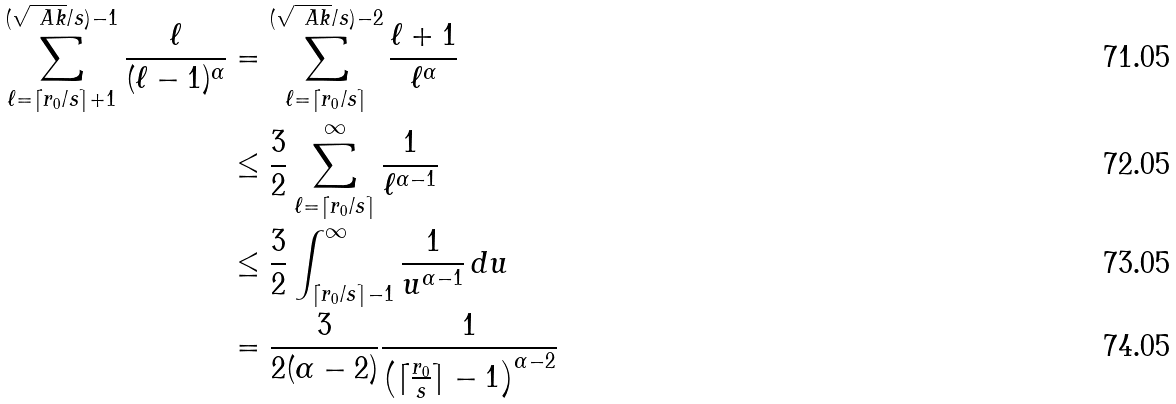<formula> <loc_0><loc_0><loc_500><loc_500>\sum _ { \ell = \lceil { r _ { 0 } } / { s } \rceil + 1 } ^ { ( { \sqrt { \ A k } } / { s } ) - 1 } \frac { \ell } { ( \ell - 1 ) ^ { \alpha } } & = \sum _ { \ell = \lceil { r _ { 0 } } / { s } \rceil } ^ { ( { \sqrt { \ A k } } / { s } ) - 2 } \frac { \ell + 1 } { \ell ^ { \alpha } } \\ & \leq \frac { 3 } { 2 } \sum _ { \ell = \lceil { r _ { 0 } } / { s } \rceil } ^ { \infty } \frac { 1 } { \ell ^ { \alpha - 1 } } \\ & \leq \frac { 3 } { 2 } \int _ { \lceil r _ { 0 } / s \rceil - 1 } ^ { \infty } \frac { 1 } { u ^ { \alpha - 1 } } \, d u \\ & = \frac { 3 } { 2 ( \alpha - 2 ) } \frac { 1 } { \left ( \lceil \frac { r _ { 0 } } { s } \rceil - 1 \right ) ^ { \alpha - 2 } }</formula> 